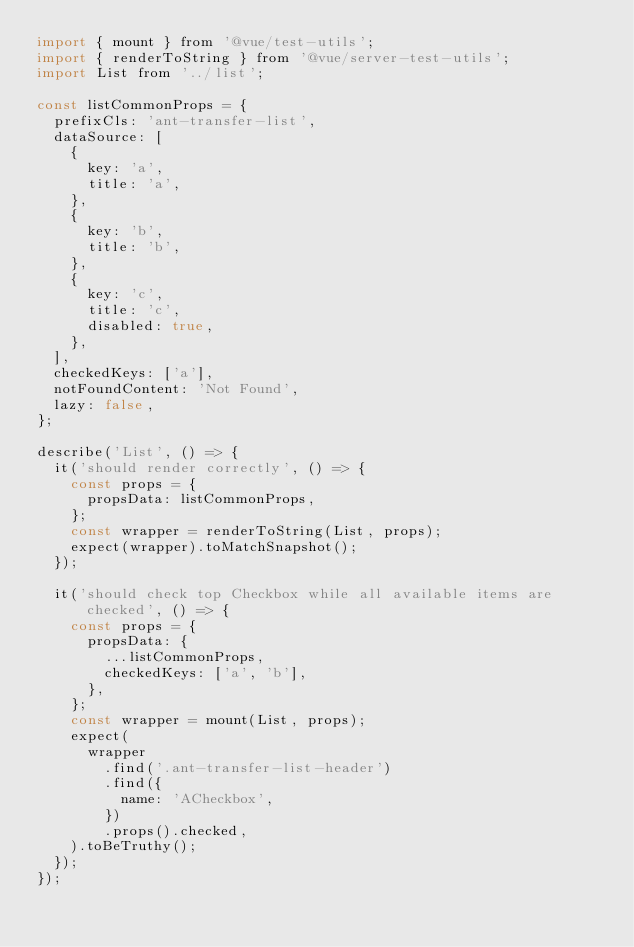Convert code to text. <code><loc_0><loc_0><loc_500><loc_500><_JavaScript_>import { mount } from '@vue/test-utils';
import { renderToString } from '@vue/server-test-utils';
import List from '../list';

const listCommonProps = {
  prefixCls: 'ant-transfer-list',
  dataSource: [
    {
      key: 'a',
      title: 'a',
    },
    {
      key: 'b',
      title: 'b',
    },
    {
      key: 'c',
      title: 'c',
      disabled: true,
    },
  ],
  checkedKeys: ['a'],
  notFoundContent: 'Not Found',
  lazy: false,
};

describe('List', () => {
  it('should render correctly', () => {
    const props = {
      propsData: listCommonProps,
    };
    const wrapper = renderToString(List, props);
    expect(wrapper).toMatchSnapshot();
  });

  it('should check top Checkbox while all available items are checked', () => {
    const props = {
      propsData: {
        ...listCommonProps,
        checkedKeys: ['a', 'b'],
      },
    };
    const wrapper = mount(List, props);
    expect(
      wrapper
        .find('.ant-transfer-list-header')
        .find({
          name: 'ACheckbox',
        })
        .props().checked,
    ).toBeTruthy();
  });
});
</code> 